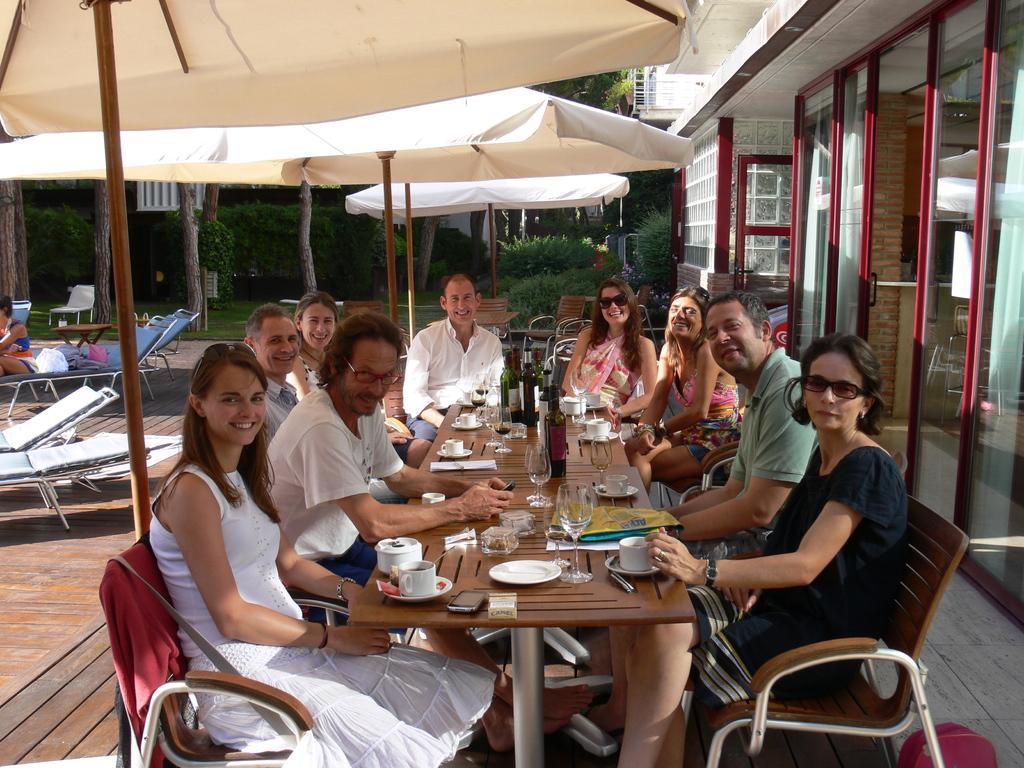How would you summarize this image in a sentence or two? This is completely an outdoor picture. On the background we can see bushes, plants and grass. Here we can see all the persons sitting on chairs in front of a table under the umbrellas and on the table we can see cups, saucers, glasses, bottle, plates, mobile. Behind to these persons we can see empty hammock chairs and a person sitting on a hammock chair. Here we can see doors. 